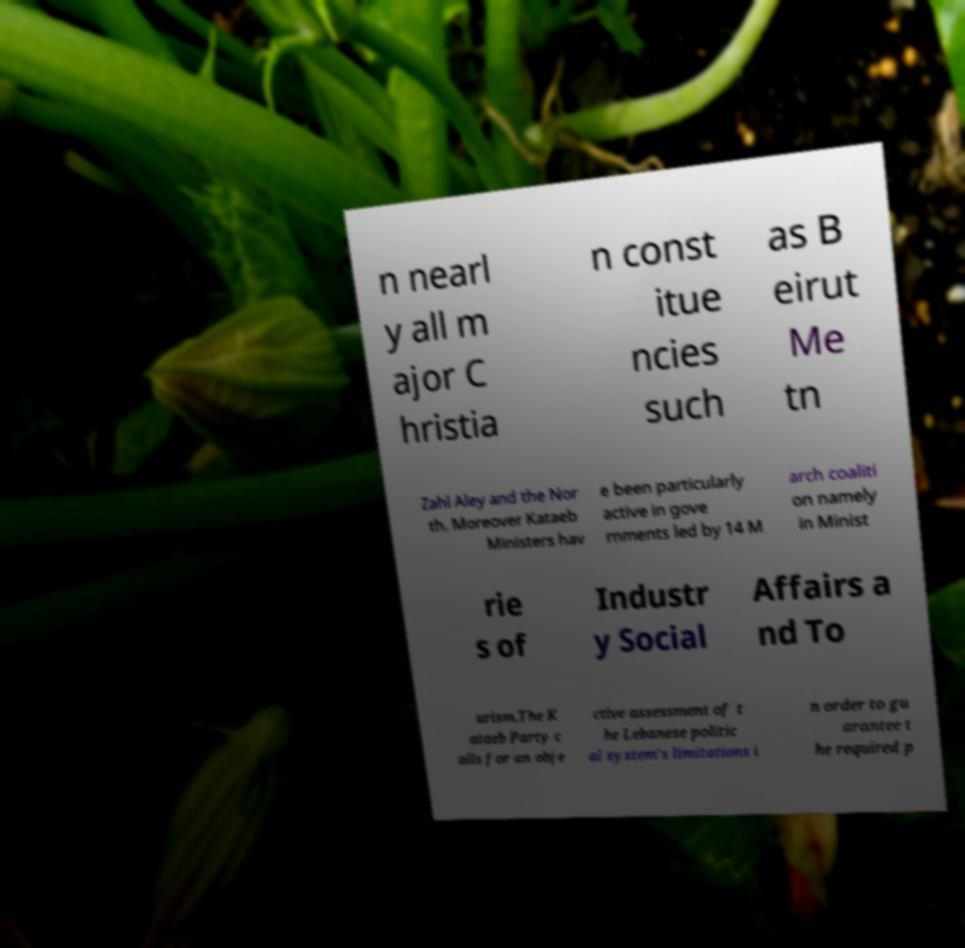For documentation purposes, I need the text within this image transcribed. Could you provide that? n nearl y all m ajor C hristia n const itue ncies such as B eirut Me tn Zahl Aley and the Nor th. Moreover Kataeb Ministers hav e been particularly active in gove rnments led by 14 M arch coaliti on namely in Minist rie s of Industr y Social Affairs a nd To urism.The K ataeb Party c alls for an obje ctive assessment of t he Lebanese politic al system's limitations i n order to gu arantee t he required p 